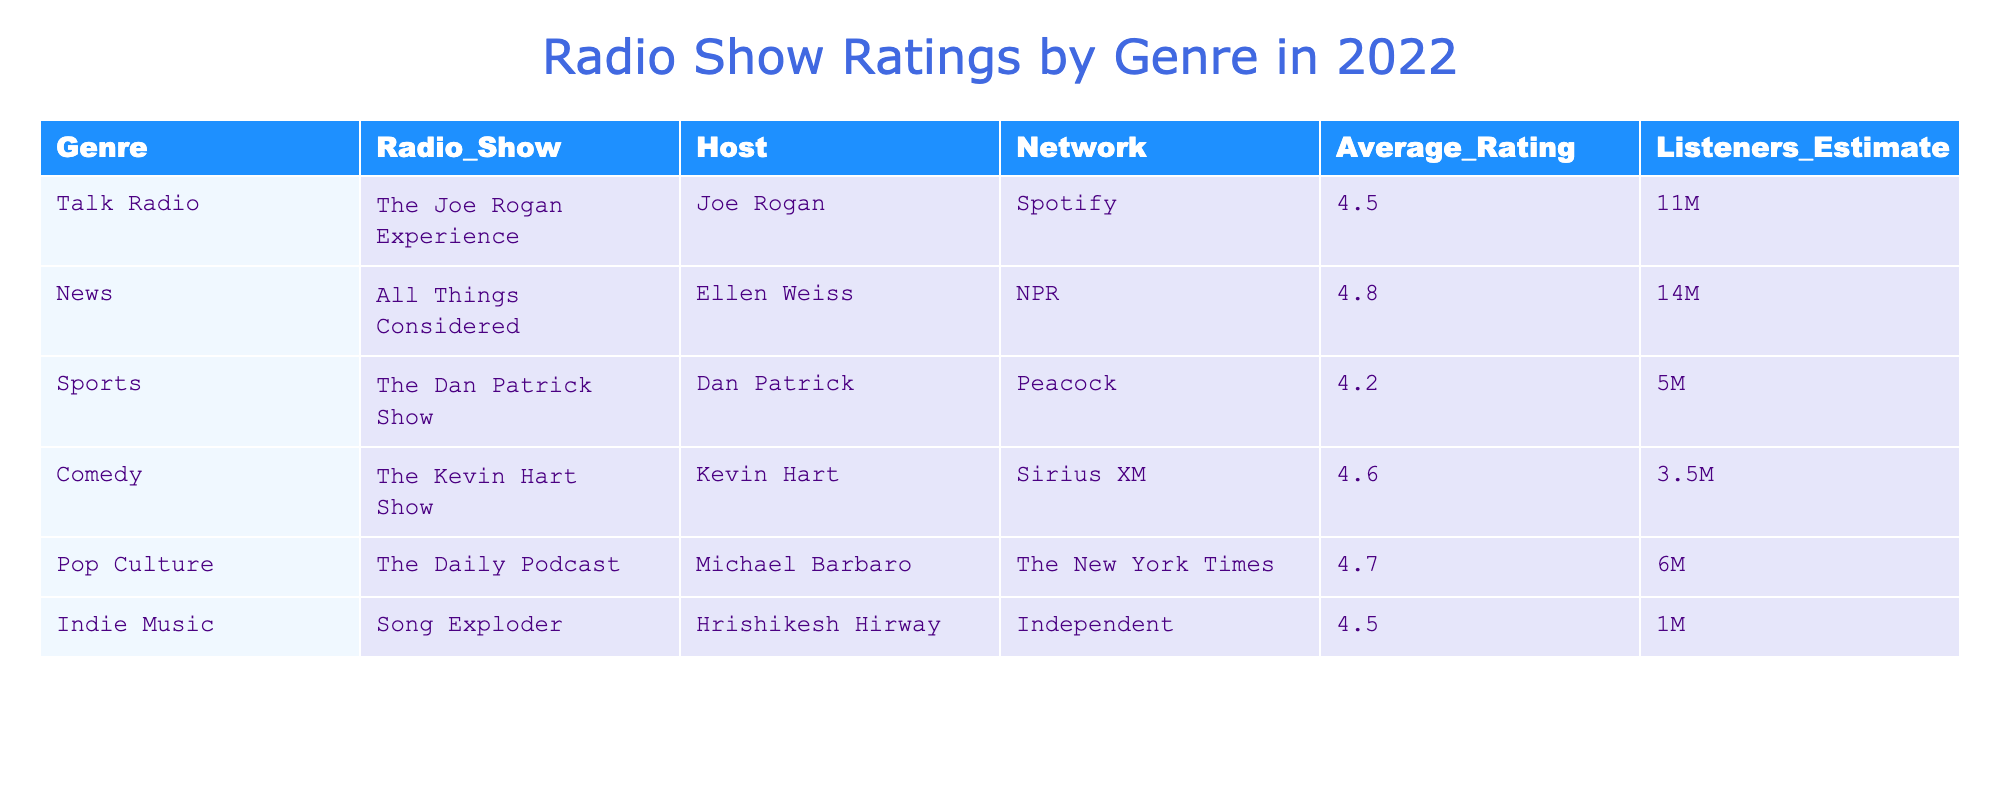What is the average rating of "All Things Considered"? The average rating for the show "All Things Considered" is directly stated in the table as 4.8.
Answer: 4.8 Which radio show genres received an average rating higher than 4.5? By examining the table, the genres with average ratings higher than 4.5 are Talk Radio (4.5), News (4.8), Comedy (4.6), and Pop Culture (4.7). This includes all shows except for Sports and Indie Music.
Answer: Talk Radio, News, Comedy, Pop Culture How many listeners does "The Joe Rogan Experience" have compared to "The Dan Patrick Show"? "The Joe Rogan Experience" has an estimated 11 million listeners, whereas "The Dan Patrick Show" has 5 million. The difference is calculated: 11M - 5M = 6M.
Answer: 6 million more listeners Which genre has the highest average rating and what is that rating? By checking the ratings in the table, "All Things Considered" under the News genre has the highest average rating of 4.8.
Answer: News, 4.8 If we average the ratings for Comedy and Sports genres, what would it be? The average rating for Comedy is 4.6 and for Sports, it is 4.2. We add them: 4.6 + 4.2 = 8.8, then divide by 2: 8.8/2 = 4.4.
Answer: 4.4 Does "Song Exploder" have more listeners than "The Kevin Hart Show"? "Song Exploder" has approximately 1 million listeners while "The Kevin Hart Show" has approximately 3.5 million listeners, therefore, it does not.
Answer: No Which show has the least estimated number of listeners? The show with the least estimated number of listeners is "Song Exploder" with only 1 million.
Answer: Song Exploder What is the combined total estimate of listeners for Talk Radio and Pop Culture genres? The estimated number of listeners for Talk Radio is 11 million and for Pop Culture is 6 million. Combining them gives: 11M + 6M = 17M.
Answer: 17 million Is the average rating for Sports higher than the average for Indie Music? The average rating for Sports is 4.2 while for Indie Music, it's 4.5. Since 4.2 is less than 4.5, the statement is false.
Answer: No If you rank the shows by average rating, which show comes second? The ratings in order from highest to lowest are: All Things Considered (4.8), Comedy (4.6), The Joe Rogan Experience (4.5), Indie Music (4.5), Pop Culture (4.7), and Sports (4.2). Therefore, the second show based on average rating is "The Daily Podcast" which belongs to Pop Culture.
Answer: The Daily Podcast 